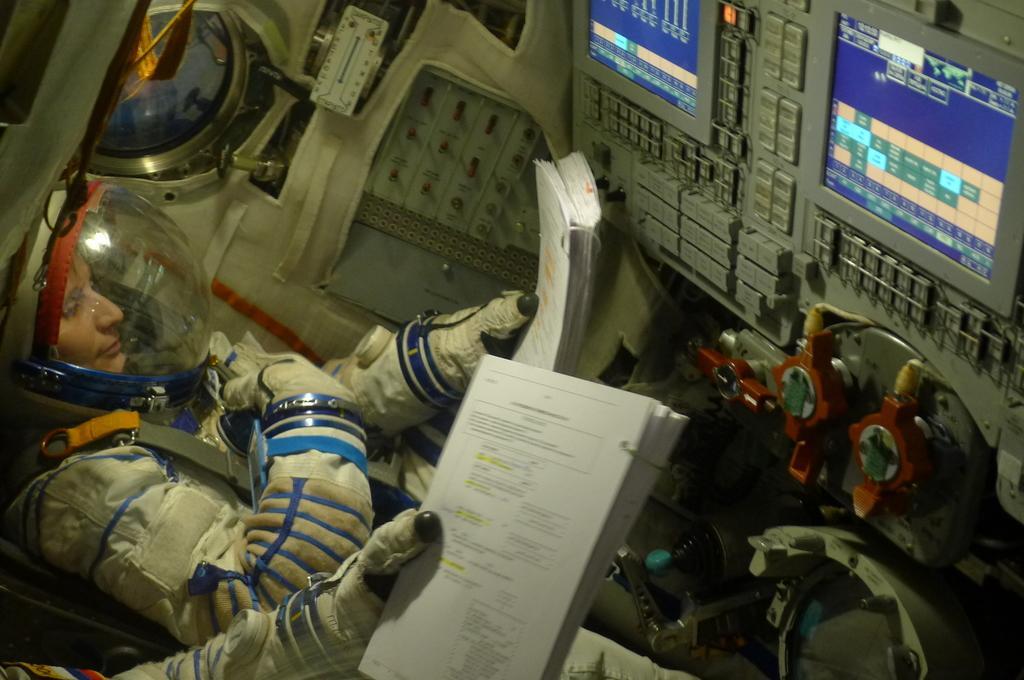In one or two sentences, can you explain what this image depicts? In this image there are some spaceman's holding books, in front of them there are some machines. 